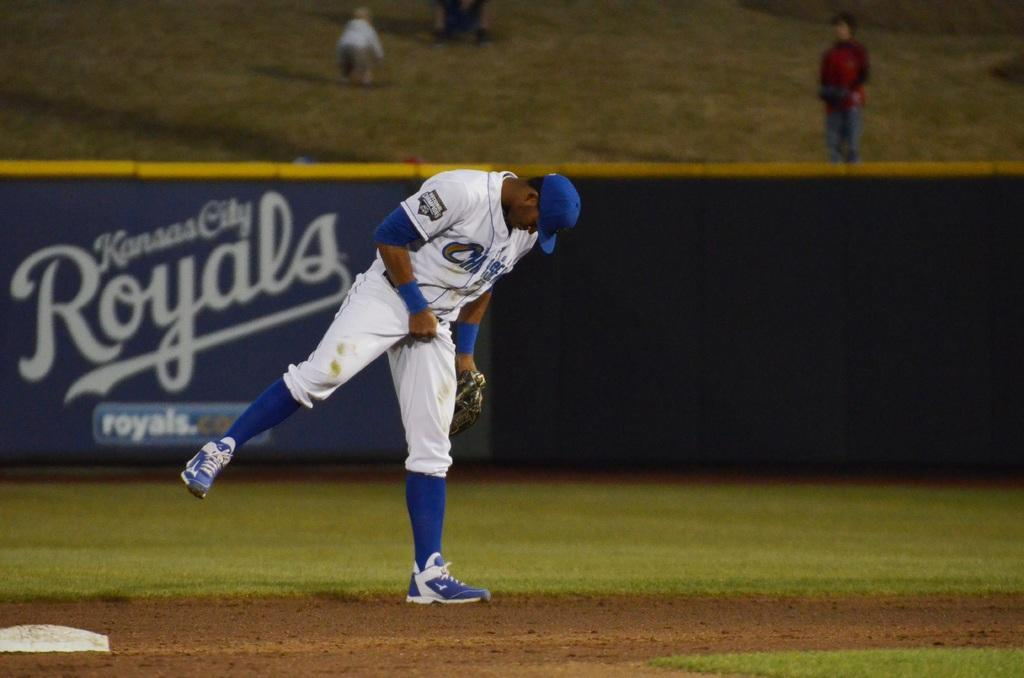<image>
Relay a brief, clear account of the picture shown. Baseball player standing at the plate with the name Kansas City Royals in the background. 